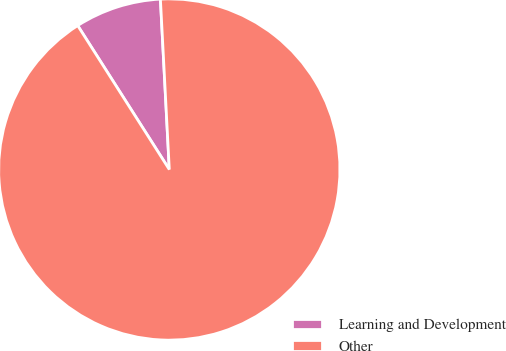<chart> <loc_0><loc_0><loc_500><loc_500><pie_chart><fcel>Learning and Development<fcel>Other<nl><fcel>8.19%<fcel>91.81%<nl></chart> 